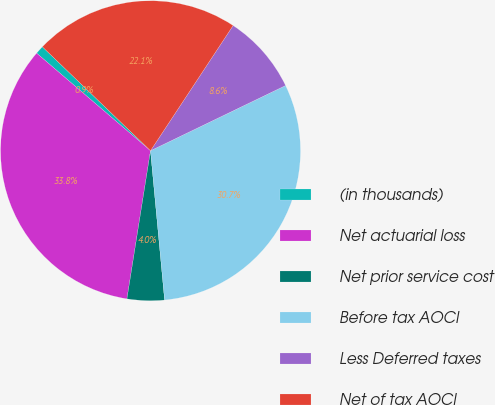Convert chart to OTSL. <chart><loc_0><loc_0><loc_500><loc_500><pie_chart><fcel>(in thousands)<fcel>Net actuarial loss<fcel>Net prior service cost<fcel>Before tax AOCI<fcel>Less Deferred taxes<fcel>Net of tax AOCI<nl><fcel>0.91%<fcel>33.76%<fcel>4.01%<fcel>30.66%<fcel>8.56%<fcel>22.1%<nl></chart> 